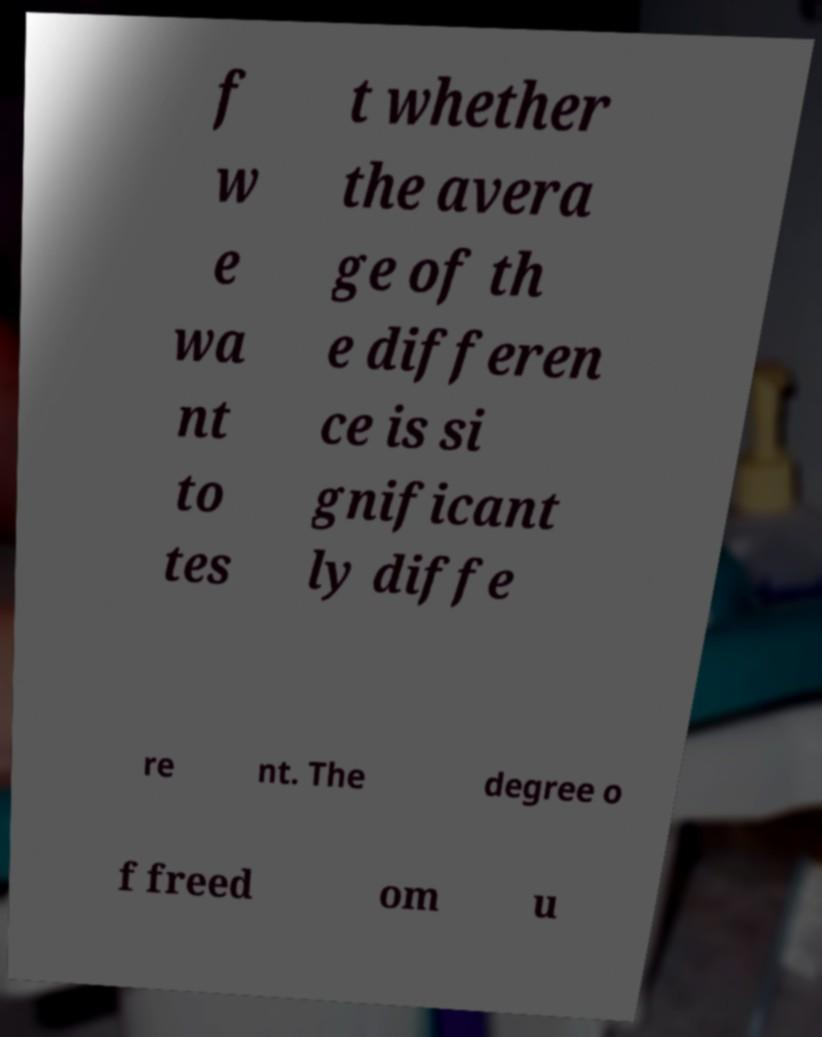What messages or text are displayed in this image? I need them in a readable, typed format. f w e wa nt to tes t whether the avera ge of th e differen ce is si gnificant ly diffe re nt. The degree o f freed om u 